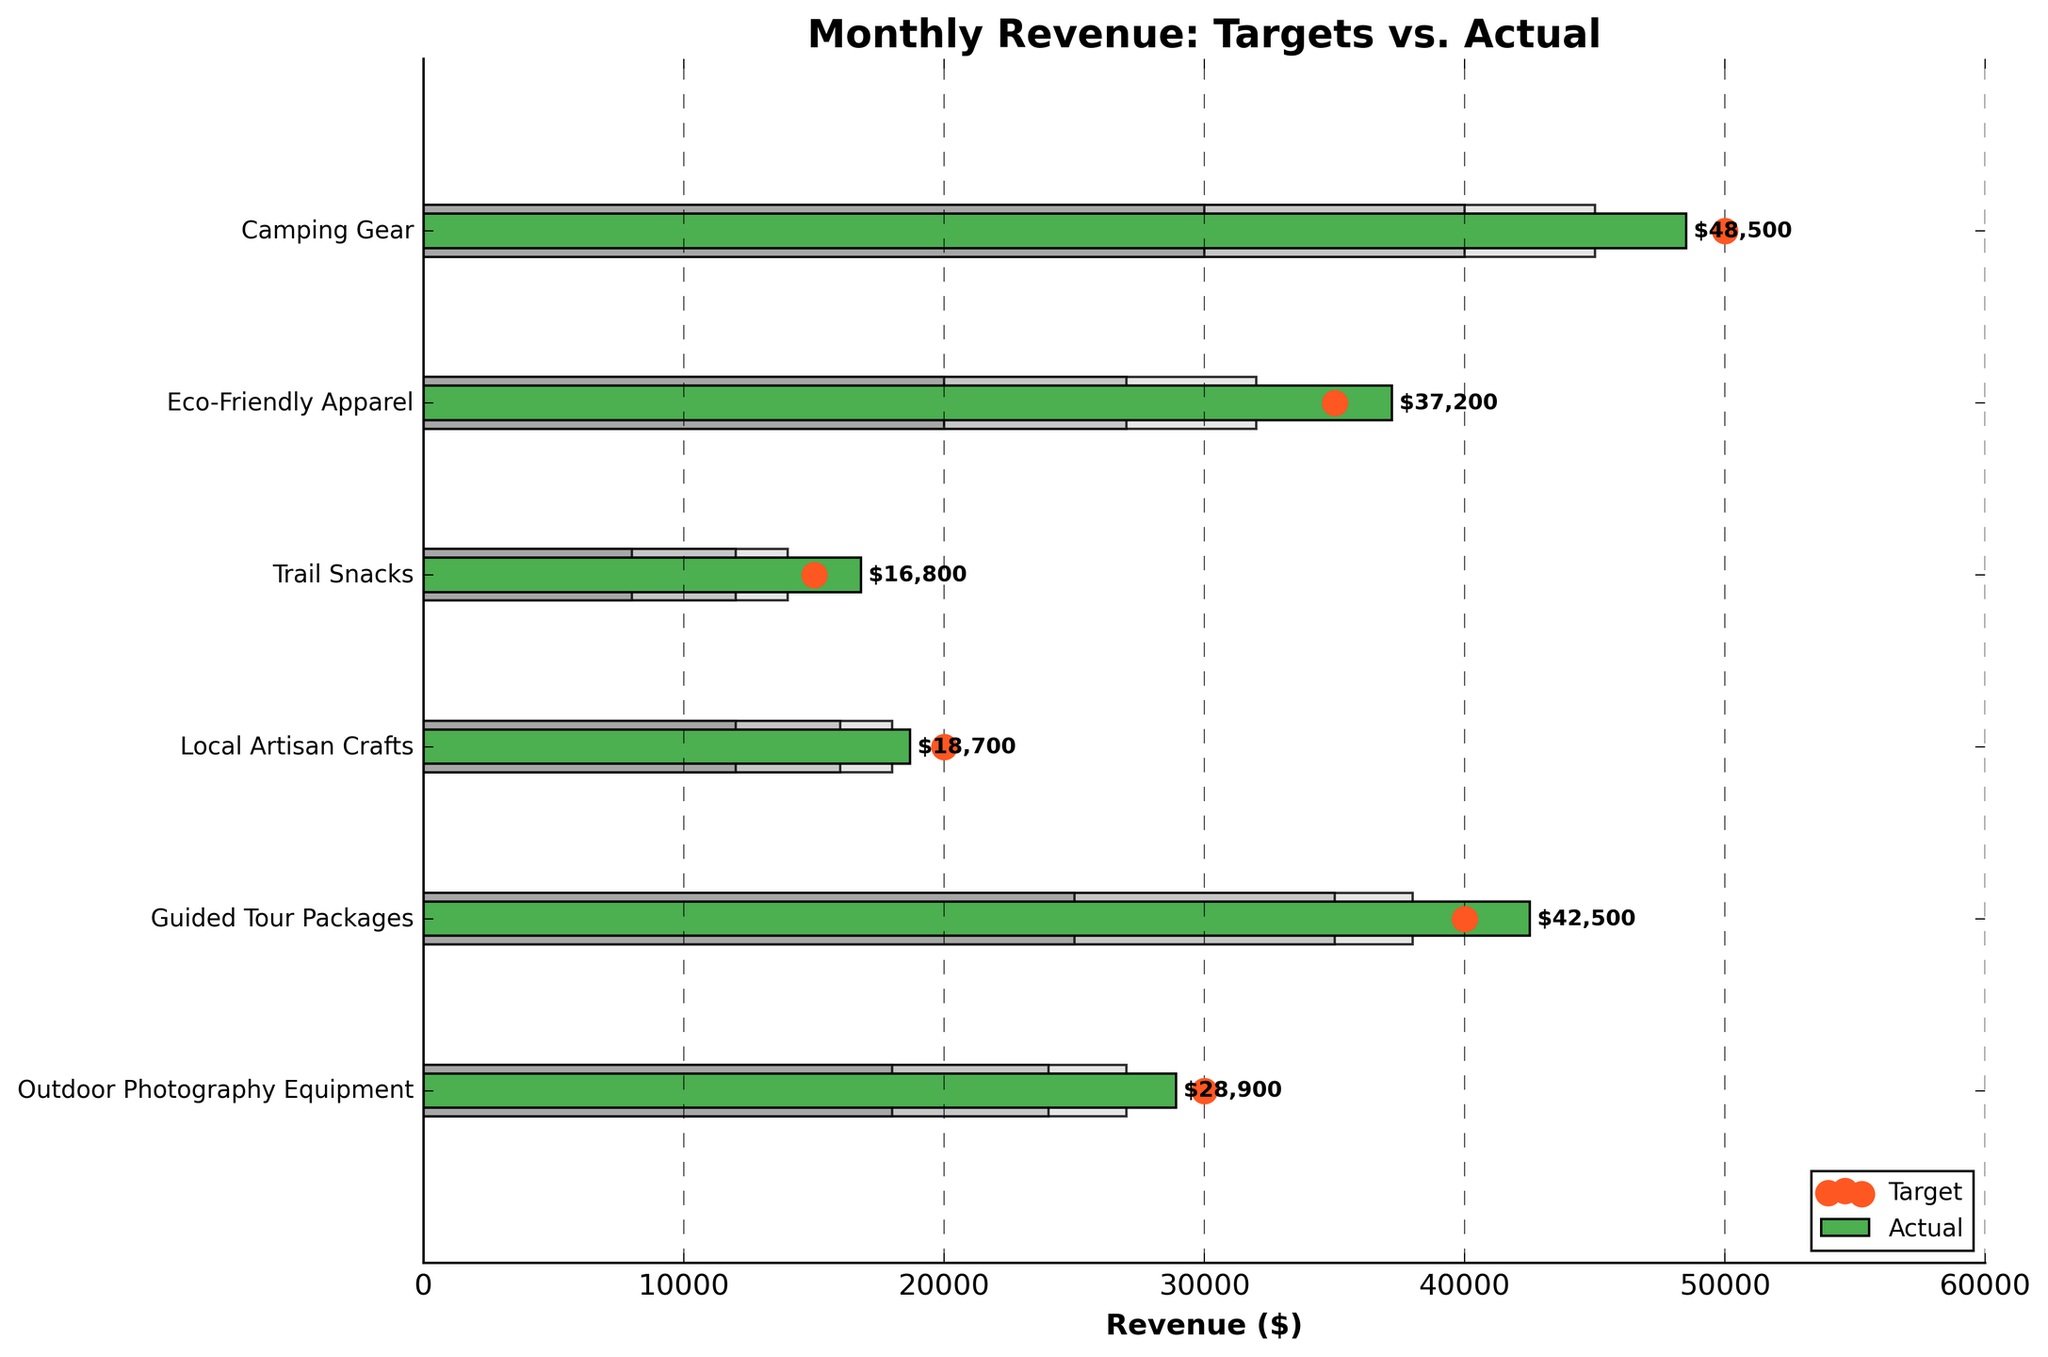What's the title of the figure? The title of the figure is displayed at the top and describes the content of the chart.
Answer: Monthly Revenue: Targets vs. Actual What does the color green represent in the chart? The color green is used to indicate the actual revenue for each product category.
Answer: Actual revenue What category exceeded its target revenue? To find this, compare the actual and target revenue for each category. The actual revenue for "Guided Tour Packages" ($42,500) is higher than its target ($40,000).
Answer: Guided Tour Packages Which category had the closest actual revenue to its target? By comparing the difference between actual and target revenues, "Camping Gear" had an actual revenue of $48,500, which is closest to its target of $50,000, with a difference of $1,500.
Answer: Camping Gear How much revenue did "Trail Snacks" earn above its higher range limit? The higher range limit for "Trail Snacks" is $14,000, and the actual revenue is $16,800. The difference is $16,800 - $14,000.
Answer: $2,800 Which category fell short of its target by the greatest amount? Calculate the difference between target and actual revenues for each category. "Local Artisan Crafts" had a target of $20,000 and an actual of $18,700, with a difference of $1,300.
Answer: Local Artisan Crafts What is the total actual revenue across all categories? Sum the actual revenues: $48,500 + $37,200 + $16,800 + $18,700 + $42,500 + $28,900 = $192,600.
Answer: $192,600 